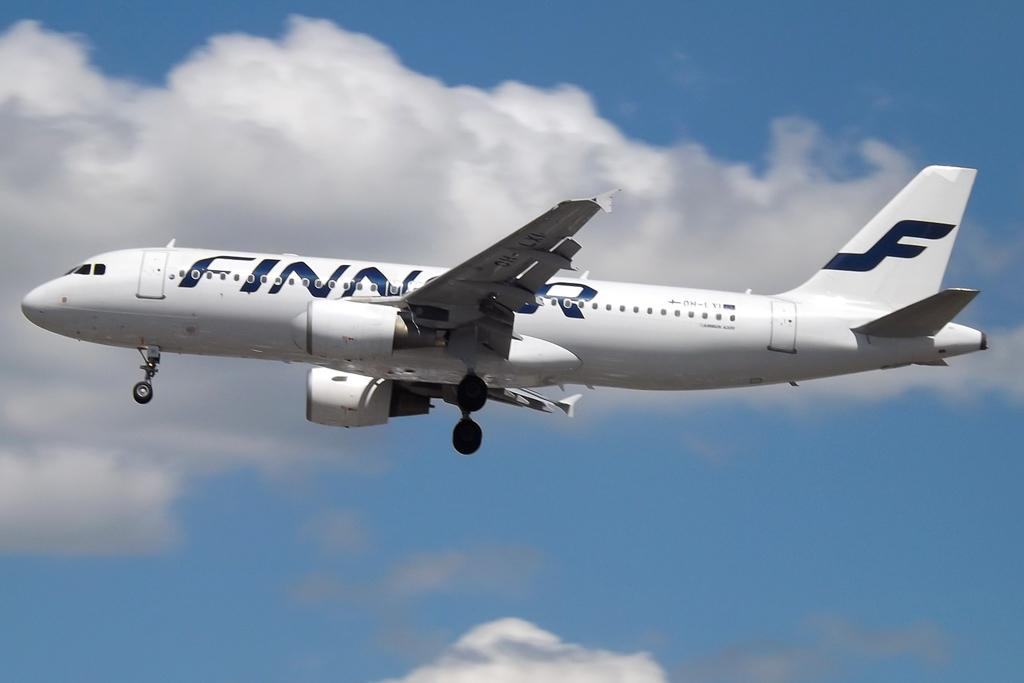Provide a one-sentence caption for the provided image. A large white airplane is flying in the sky and on the side it says FINNAIR in black. 